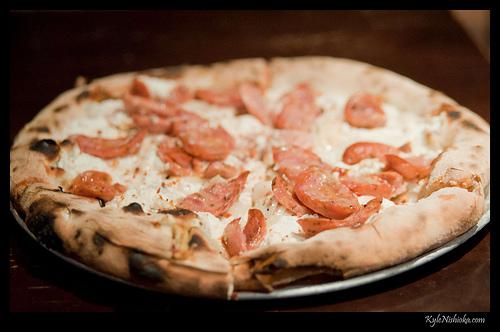Question: what color is the sausage?
Choices:
A. Red.
B. Pink.
C. Brown.
D. Green.
Answer with the letter. Answer: A Question: where is the pizza?
Choices:
A. On a plate.
B. Oven.
C. Table.
D. Box.
Answer with the letter. Answer: A Question: why was the pizza made?
Choices:
A. To be eaten.
B. For delivery.
C. For freezing for later.
D. For shipment.
Answer with the letter. Answer: A 